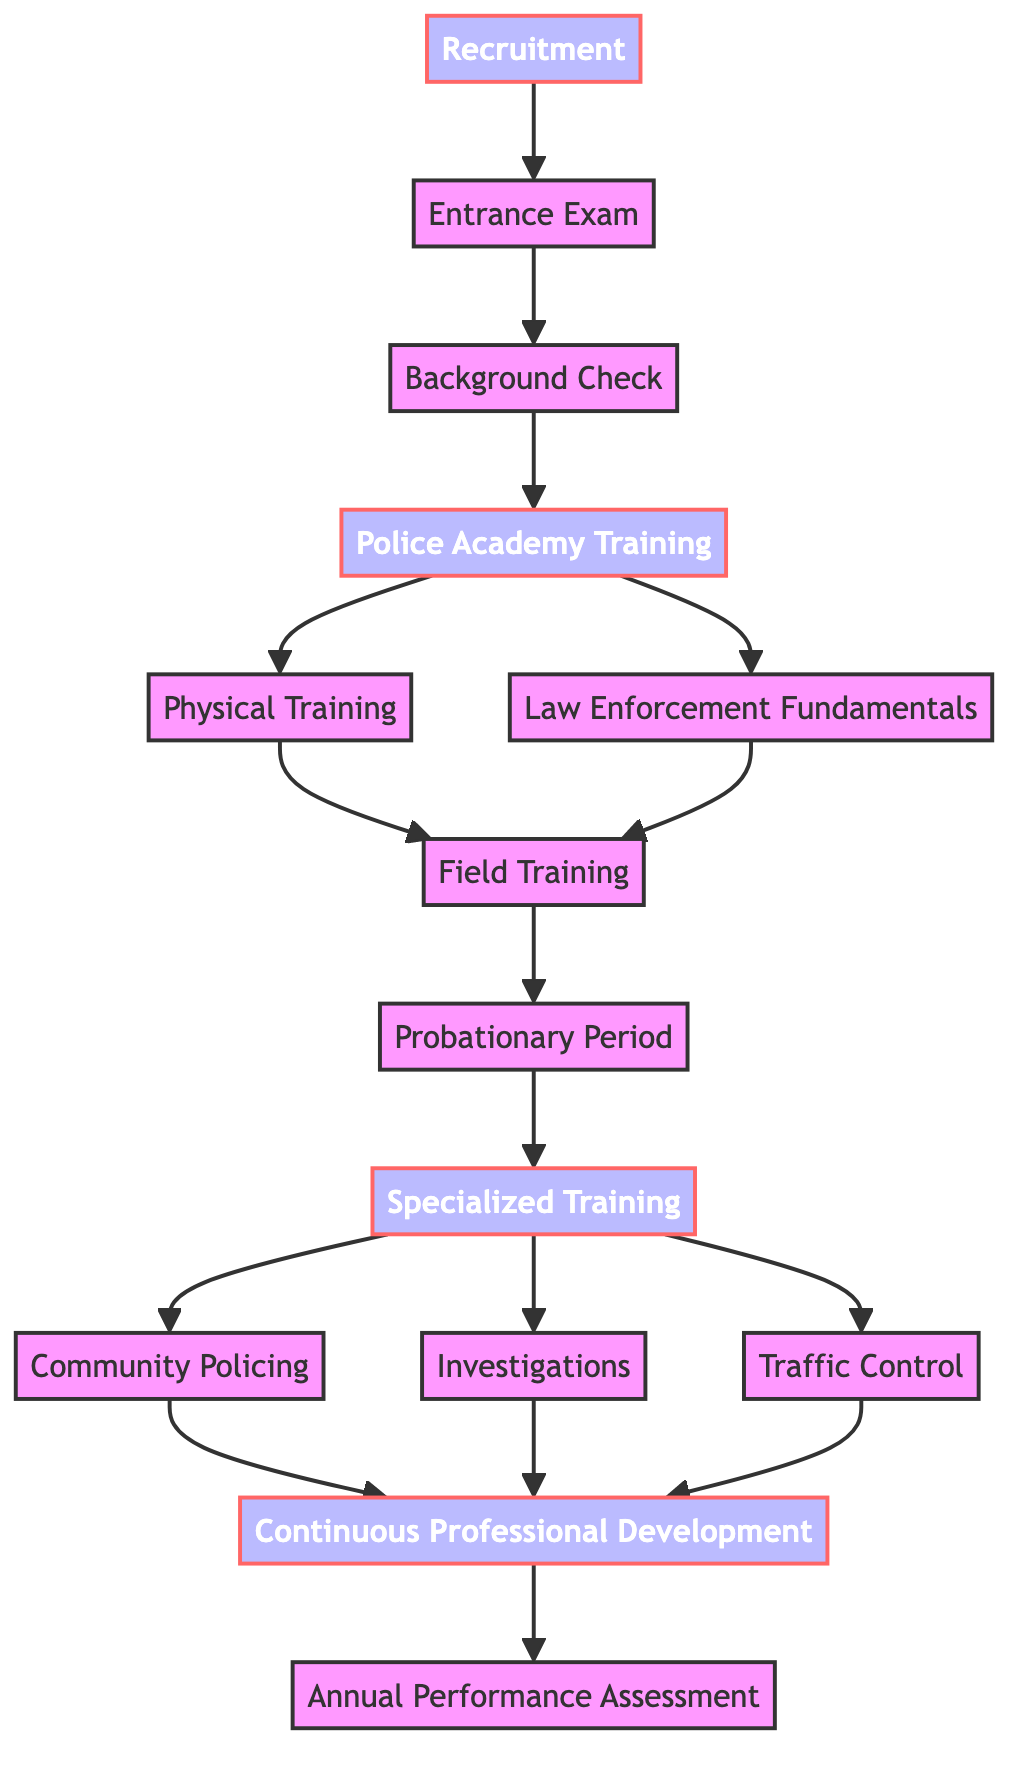What is the first stage in the officer training program? The diagram shows "Recruitment" as the first node and starting point of the training program progression.
Answer: Recruitment How many specialized training areas are listed? The diagram shows three branches stemming from "Specialized Training": Traffic Control, Investigations, and Community Policing, indicating there are three areas.
Answer: Three Which node directly follows the "Field Training" node? Following the "Field Training" node, the next node is "Probationary Period," as evident from the edge leading from "Field Training" to "Probationary Period."
Answer: Probationary Period What is the final assessment stage in the training progression? According to the diagram, the final node in the training progression is "Annual Performance Assessment," indicating it is the last stage.
Answer: Annual Performance Assessment From which node does "Continuous Professional Development" originate? "Continuous Professional Development" has three incoming edges from "Community Policing," "Investigations," and "Traffic Control," meaning it originates from these specialized areas.
Answer: Community Policing, Investigations, Traffic Control How many nodes are connected to the "Specialized Training" node? The "Specialized Training" node branches out to three nodes: Traffic Control, Investigations, and Community Policing, indicating it has three connections.
Answer: Three What is the relationship between "Academy Training" and "Physical Training"? The edge from "Academy Training" to "Physical Training" signifies that "Physical Training" follows "Academy Training" in the training sequence.
Answer: Follows Is there any node that connects back to a previous stage? In this directed graph, nodes do not connect back to previous stages; it represents a one-way progression from recruitment through to assessments.
Answer: No 